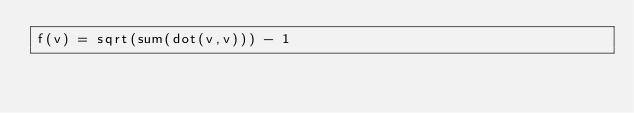Convert code to text. <code><loc_0><loc_0><loc_500><loc_500><_Julia_>f(v) = sqrt(sum(dot(v,v))) - 1</code> 